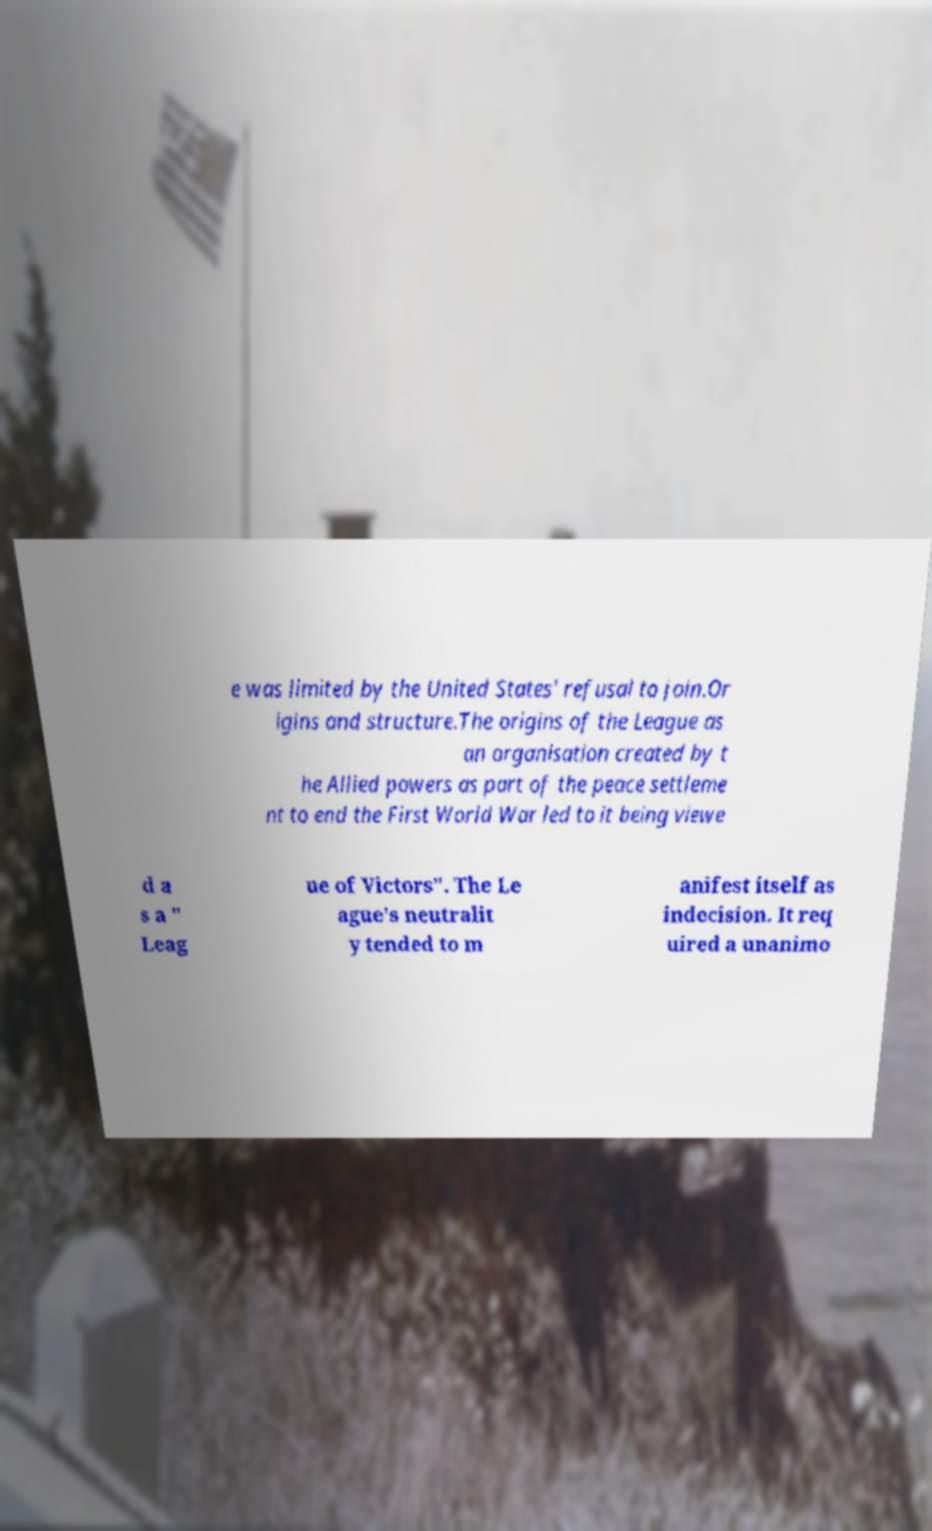Could you assist in decoding the text presented in this image and type it out clearly? e was limited by the United States' refusal to join.Or igins and structure.The origins of the League as an organisation created by t he Allied powers as part of the peace settleme nt to end the First World War led to it being viewe d a s a " Leag ue of Victors". The Le ague's neutralit y tended to m anifest itself as indecision. It req uired a unanimo 